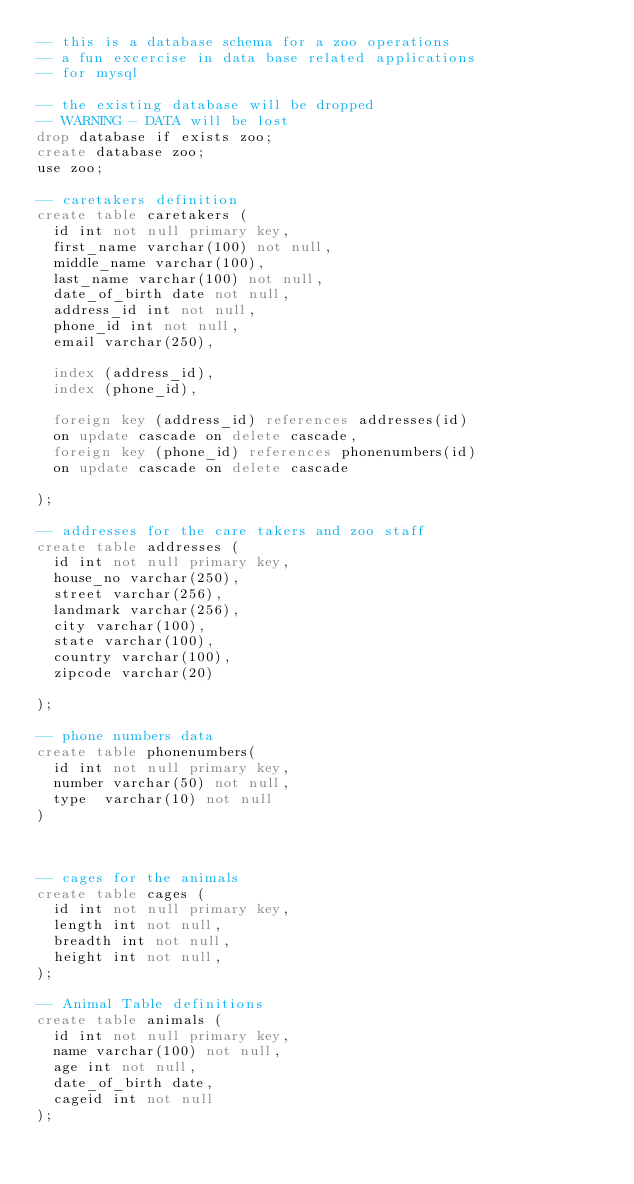<code> <loc_0><loc_0><loc_500><loc_500><_SQL_>-- this is a database schema for a zoo operations 
-- a fun excercise in data base related applications
-- for mysql 

-- the existing database will be dropped 
-- WARNING - DATA will be lost 
drop database if exists zoo;
create database zoo;
use zoo;

-- caretakers definition 
create table caretakers (
	id int not null primary key, 
	first_name varchar(100) not null,
	middle_name varchar(100),
	last_name varchar(100) not null,
	date_of_birth date not null,
	address_id int not null,
	phone_id int not null,
	email varchar(250),

	index (address_id),
	index (phone_id),

	foreign key (address_id) references addresses(id)
	on update cascade on delete cascade,
	foreign key (phone_id) references phonenumbers(id) 
	on update cascade on delete cascade 
	
);

-- addresses for the care takers and zoo staff 
create table addresses (
	id int not null primary key,
	house_no varchar(250),
	street varchar(256),
	landmark varchar(256),
	city varchar(100),
	state varchar(100),
	country varchar(100),
	zipcode varchar(20)

);

-- phone numbers data 
create table phonenumbers(
	id int not null primary key, 
	number varchar(50) not null, 
	type  varchar(10) not null
)



-- cages for the animals 
create table cages (
	id int not null primary key,
	length int not null, 
	breadth int not null,
	height int not null, 
);

-- Animal Table definitions
create table animals (
	id int not null primary key, 
	name varchar(100) not null,
	age int not null,
	date_of_birth date,
	cageid int not null 
);</code> 